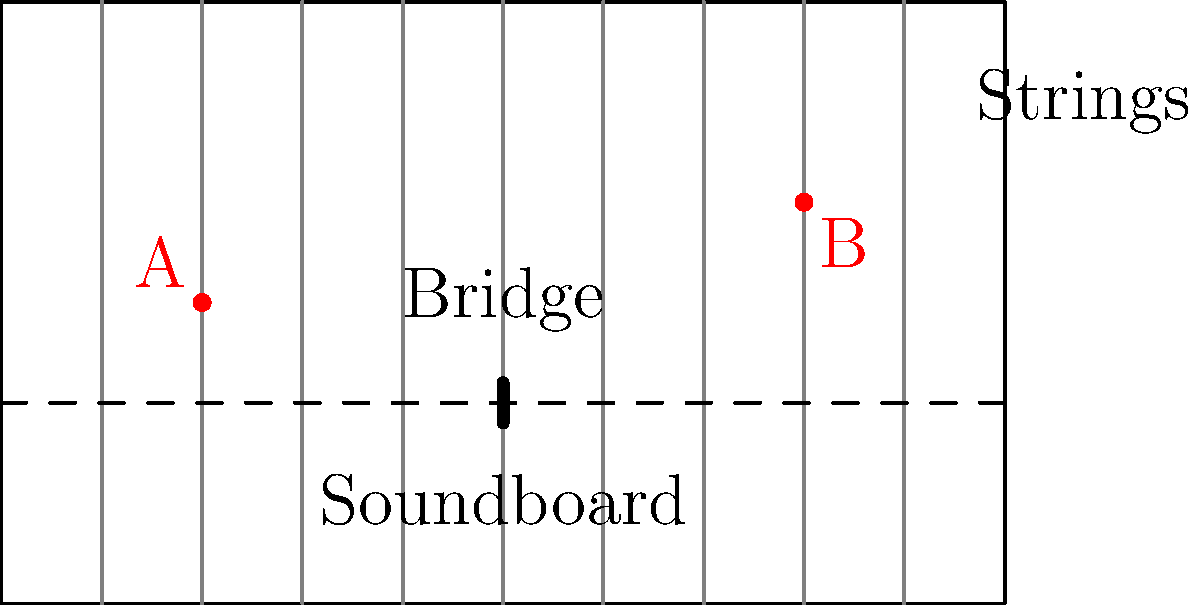In the topological analysis of a grand piano, consider the simplified diagram above. If we were to create a continuous deformation of the piano's structure, which of the following statements would be true from a topological perspective?

1. The soundboard and the strings form a disconnected space.
2. The bridge is homeomorphic to a point.
3. Points A and B on different strings can be connected without crossing the bridge.
4. The piano's overall shape is homeomorphic to a torus. Let's analyze each statement from a topological perspective:

1. The soundboard and strings form a disconnected space:
   This is false. In a real piano, the strings are connected to the soundboard via the bridge. Topologically, they form a connected space.

2. The bridge is homeomorphic to a point:
   This is true. The bridge, despite its physical importance, can be continuously deformed into a single point without changing the topological properties of the piano's structure.

3. Points A and B on different strings can be connected without crossing the bridge:
   This is false. In the topological representation, the strings are separated by the bridge. To connect points on different strings, any path would need to cross the bridge or exit the piano's boundary.

4. The piano's overall shape is homeomorphic to a torus:
   This is false. The piano's shape, as shown, is topologically equivalent to a solid rectangular prism, which is homeomorphic to a solid sphere, not a torus. A torus has a hole through it, which the piano doesn't have.

The key topological features to consider are:
- Connectedness of the structure
- The dimensionality of components (e.g., strings as 1D objects, soundboard as 2D)
- The overall genus of the shape (number of holes)

Given these considerations, the only topologically correct statement is that the bridge is homeomorphic to a point.
Answer: The bridge is homeomorphic to a point. 